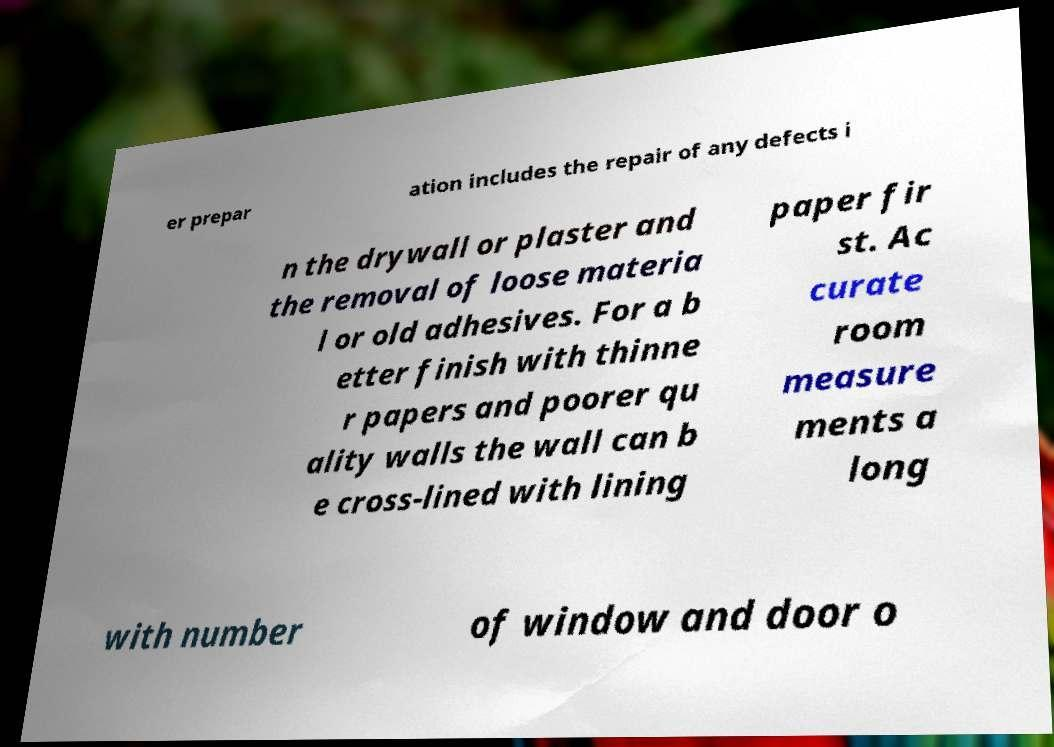Can you accurately transcribe the text from the provided image for me? er prepar ation includes the repair of any defects i n the drywall or plaster and the removal of loose materia l or old adhesives. For a b etter finish with thinne r papers and poorer qu ality walls the wall can b e cross-lined with lining paper fir st. Ac curate room measure ments a long with number of window and door o 